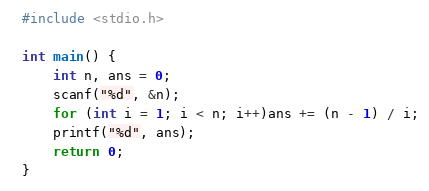<code> <loc_0><loc_0><loc_500><loc_500><_C_>#include <stdio.h>

int main() {
	int n, ans = 0;
	scanf("%d", &n);
	for (int i = 1; i < n; i++)ans += (n - 1) / i;
	printf("%d", ans);
	return 0;
}</code> 